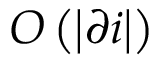Convert formula to latex. <formula><loc_0><loc_0><loc_500><loc_500>O \left ( \left | \partial i \right | \right )</formula> 